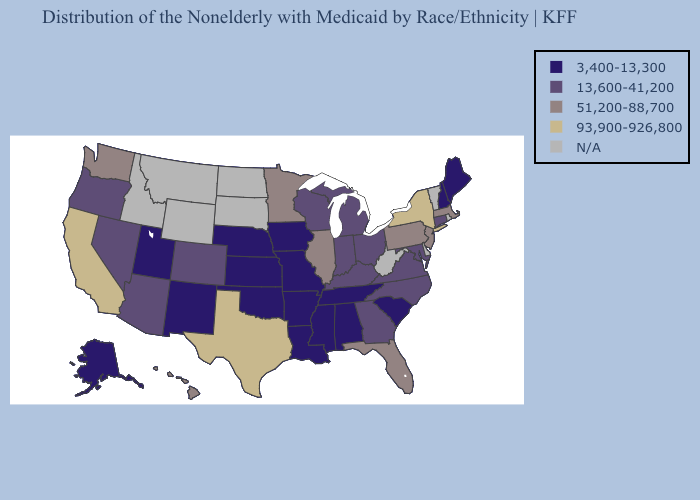Name the states that have a value in the range 93,900-926,800?
Be succinct. California, New York, Texas. Among the states that border Oklahoma , does Missouri have the highest value?
Quick response, please. No. Does the map have missing data?
Write a very short answer. Yes. What is the highest value in the USA?
Short answer required. 93,900-926,800. What is the value of Virginia?
Give a very brief answer. 13,600-41,200. What is the highest value in the USA?
Give a very brief answer. 93,900-926,800. Does the map have missing data?
Be succinct. Yes. Among the states that border Minnesota , does Wisconsin have the lowest value?
Give a very brief answer. No. What is the value of Delaware?
Quick response, please. N/A. Among the states that border Illinois , does Iowa have the highest value?
Answer briefly. No. Does South Carolina have the lowest value in the USA?
Give a very brief answer. Yes. Does Maine have the lowest value in the Northeast?
Write a very short answer. Yes. Name the states that have a value in the range 3,400-13,300?
Be succinct. Alabama, Alaska, Arkansas, Iowa, Kansas, Louisiana, Maine, Mississippi, Missouri, Nebraska, New Hampshire, New Mexico, Oklahoma, South Carolina, Tennessee, Utah. 